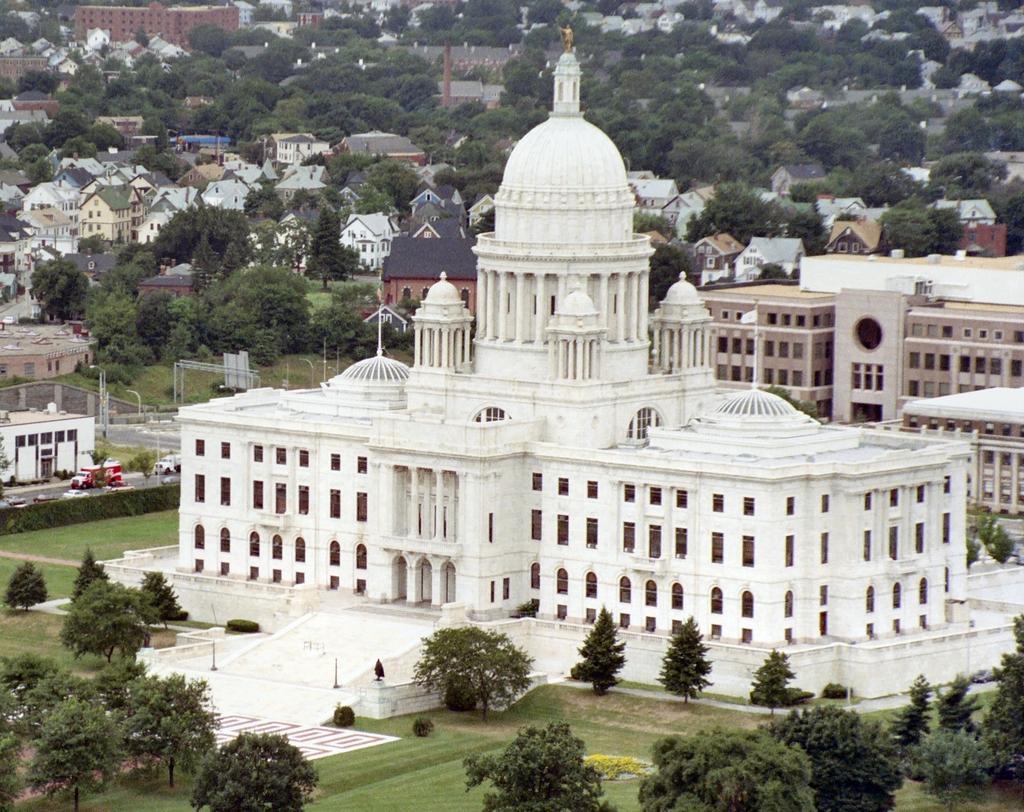Please provide a concise description of this image. In this image there are vehicles on the road. Left side there are poles and street lights. Background there are trees and buildings. Bottom of the image there are plants and trees on the grassland. 